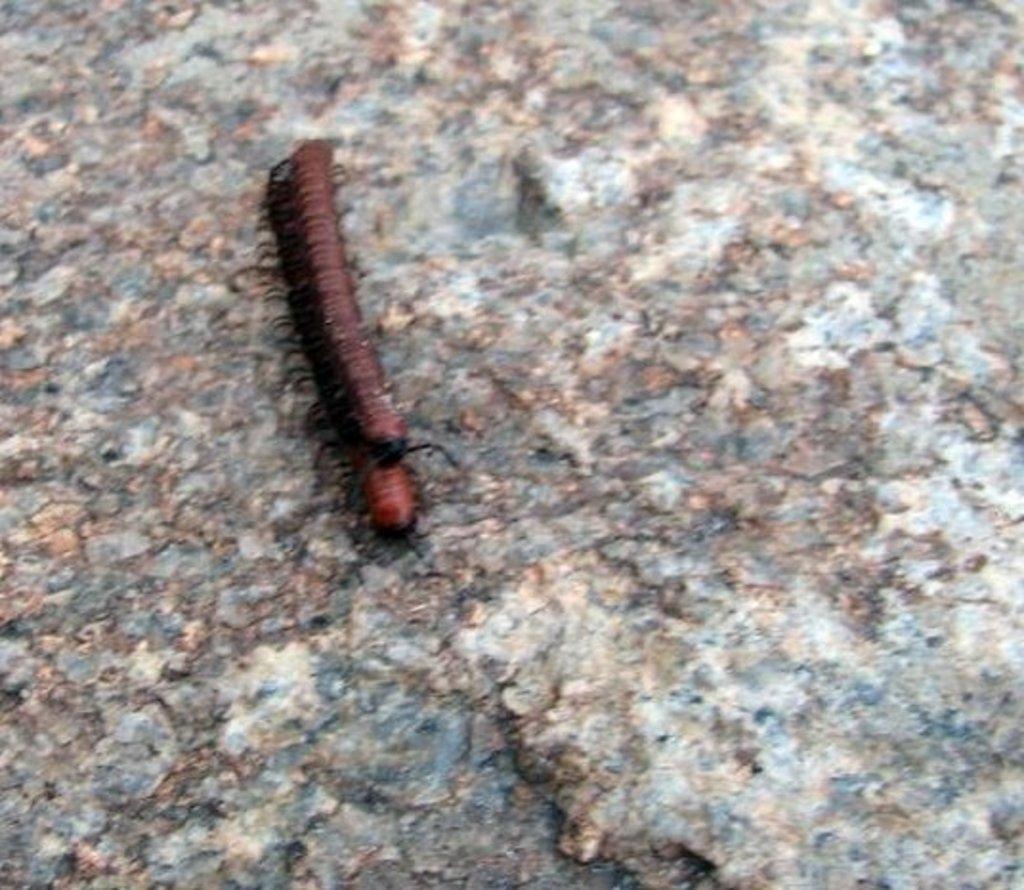Can you describe this image briefly? In this picture I can see there is a millipede on the rock. It is in red color. 